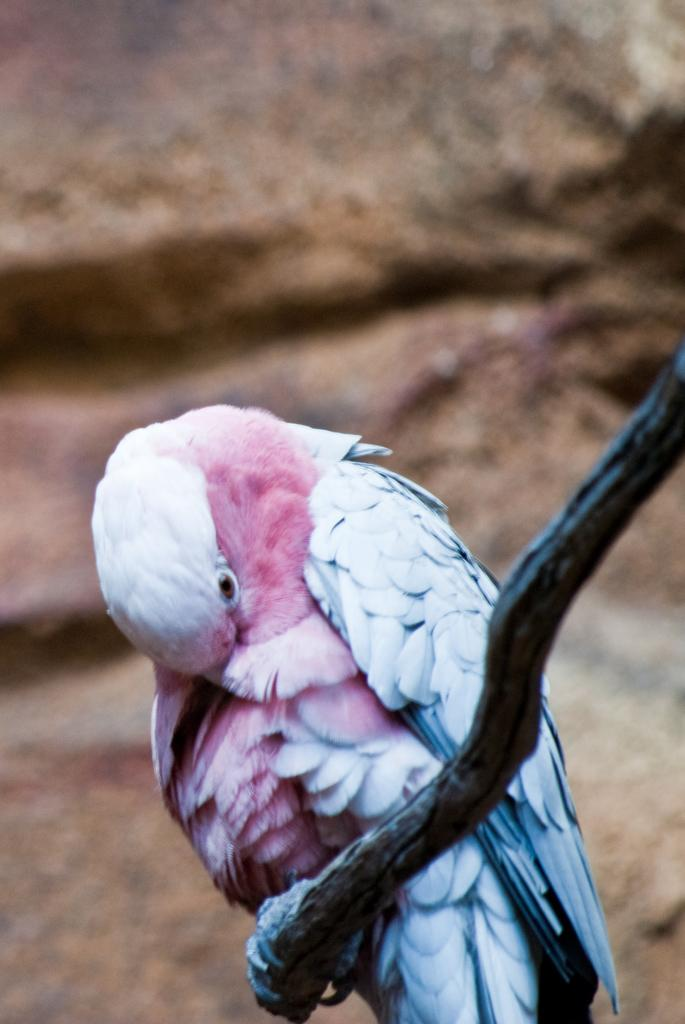What type of animal can be seen in the image? There is a bird in the image. What colors are present on the bird? The bird is white and pink in color. What is the bird sitting on? The bird is sitting on a stick. Can you describe the background of the image? The background of the image is blurred. What type of haircut does the bird have in the image? There is no indication of a haircut in the image, as birds do not have hair. 